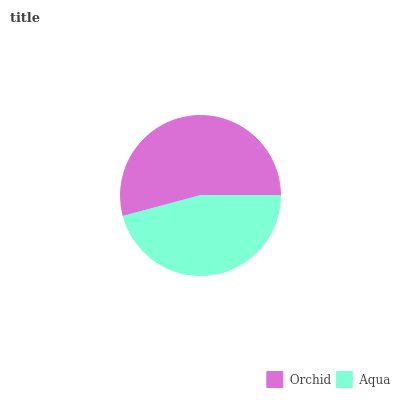Is Aqua the minimum?
Answer yes or no. Yes. Is Orchid the maximum?
Answer yes or no. Yes. Is Aqua the maximum?
Answer yes or no. No. Is Orchid greater than Aqua?
Answer yes or no. Yes. Is Aqua less than Orchid?
Answer yes or no. Yes. Is Aqua greater than Orchid?
Answer yes or no. No. Is Orchid less than Aqua?
Answer yes or no. No. Is Orchid the high median?
Answer yes or no. Yes. Is Aqua the low median?
Answer yes or no. Yes. Is Aqua the high median?
Answer yes or no. No. Is Orchid the low median?
Answer yes or no. No. 